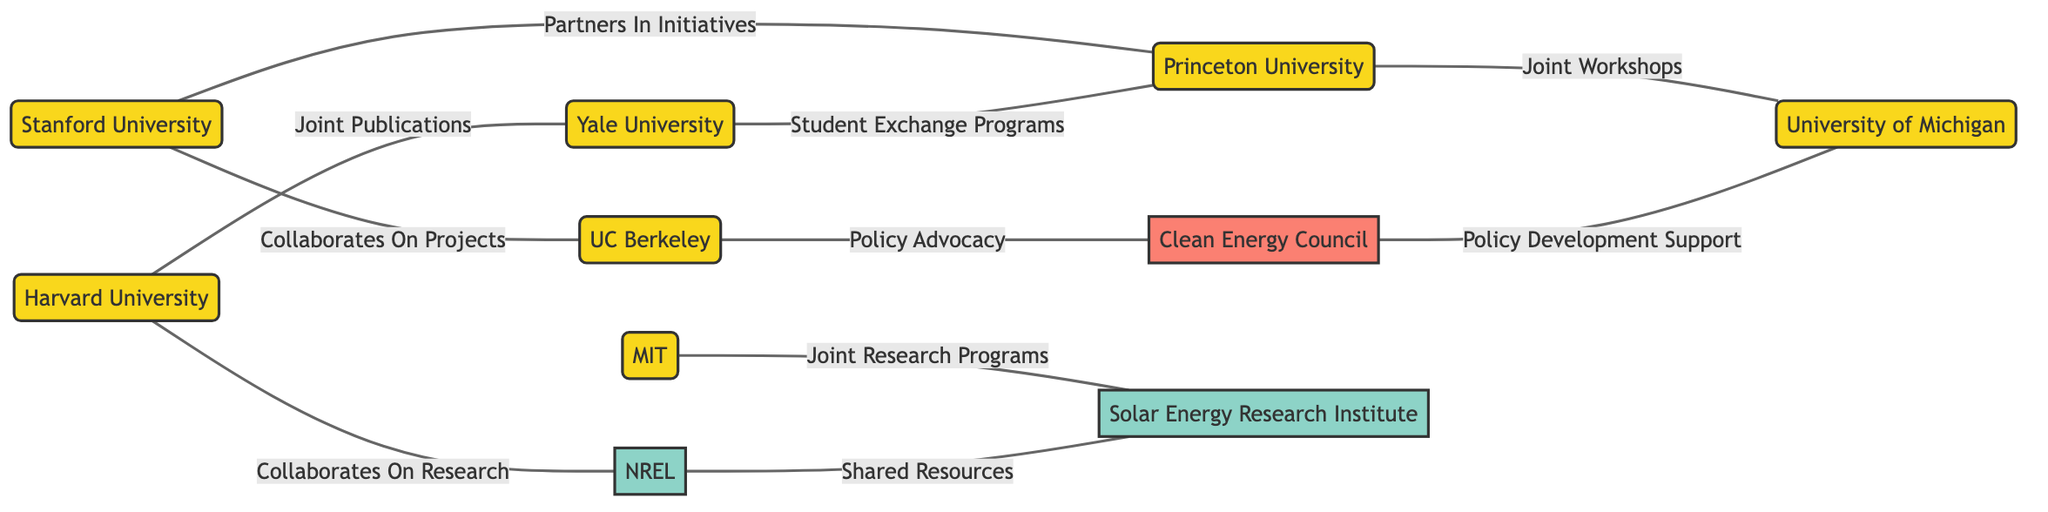What is the total number of nodes in the diagram? The diagram lists a total of 10 distinct entities, each represented as a node. Counting all the entities provides the answer.
Answer: 10 Which university has a collaboration noted for joint publications? The edge labeled "Joint Publications" connects Harvard University (node 1) and Yale University (node 6), indicating this specific collaboration.
Answer: Yale University What are the two universities that Princeton University collaborates with? By examining the edges connected to Princeton University (node 7), it shows collaborations with Stanford University (node 2) and University of Michigan (node 10).
Answer: Stanford University, University of Michigan How many research institutions are represented in the diagram? There are two research institutions in the diagram: the National Renewable Energy Laboratory (node 4) and the Solar Energy Research Institute (node 9).
Answer: 2 What type of organization advocates for policy in this network? The Clean Energy Council (node 8) has an edge labeled "Policy Advocacy" connected to University of California, Berkeley (node 5), indicating its role.
Answer: Clean Energy Council What type of connections do Harvard University and National Renewable Energy Laboratory have? The edge connecting Harvard University (node 1) and National Renewable Energy Laboratory (node 4) is labeled "Collaborates On Research," which describes their connection type.
Answer: Collaborates On Research Which university participates in joint workshops according to the diagram? The edge labeled "Joint Workshops" connects Princeton University (node 7) and University of Michigan (node 10), signifying that they participate together in workshops.
Answer: University of Michigan What is the label on the edge between University of California, Berkeley and Clean Energy Council? The edge between University of California, Berkeley (node 5) and Clean Energy Council (node 8) is labeled "Policy Advocacy," providing the specific relationship defined in the diagram.
Answer: Policy Advocacy Which university is involved in student exchange programs with Yale University? The edge labeled "Student Exchange Programs" connects Yale University (node 6) and Princeton University (node 7), indicating their partnership in student exchanges.
Answer: Princeton University What is the relationship between the Solar Energy Research Institute and National Renewable Energy Laboratory? The National Renewable Energy Laboratory (node 4) has an edge labeled "Shared Resources" connecting to the Solar Energy Research Institute (node 9), indicating their collaborative relationship.
Answer: Shared Resources 